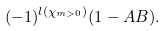Convert formula to latex. <formula><loc_0><loc_0><loc_500><loc_500>( - 1 ) ^ { l ( \chi _ { m > 0 } ) } ( 1 - A B ) .</formula> 